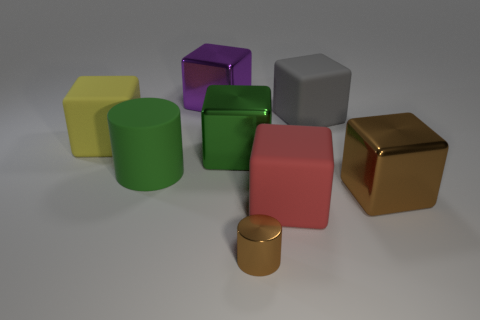Is the number of tiny brown things that are in front of the green shiny block the same as the number of gray rubber objects?
Offer a terse response. Yes. How many objects are tiny gray cylinders or large cubes that are behind the big gray cube?
Your answer should be very brief. 1. Are there any big cylinders made of the same material as the big red object?
Offer a terse response. Yes. What color is the other object that is the same shape as the small brown object?
Provide a succinct answer. Green. Is the material of the large gray cube the same as the cylinder that is on the right side of the green rubber cylinder?
Ensure brevity in your answer.  No. What is the shape of the shiny object in front of the big matte cube that is in front of the large yellow thing?
Provide a succinct answer. Cylinder. There is a block to the left of the green rubber thing; does it have the same size as the brown metal cube?
Offer a very short reply. Yes. What number of other objects are there of the same shape as the large purple thing?
Keep it short and to the point. 5. There is a large shiny block in front of the big green rubber object; is its color the same as the tiny metallic object?
Ensure brevity in your answer.  Yes. Is there a metallic thing of the same color as the big matte cylinder?
Offer a very short reply. Yes. 